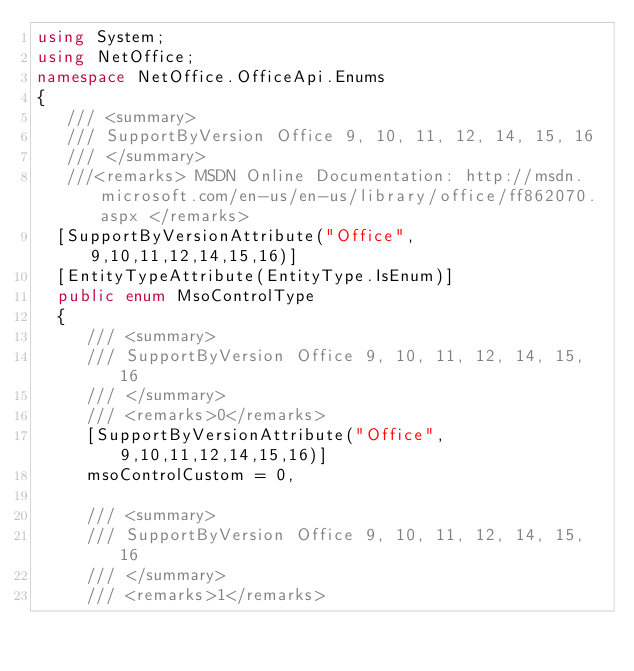Convert code to text. <code><loc_0><loc_0><loc_500><loc_500><_C#_>using System;
using NetOffice;
namespace NetOffice.OfficeApi.Enums
{
	 /// <summary>
	 /// SupportByVersion Office 9, 10, 11, 12, 14, 15, 16
	 /// </summary>
	 ///<remarks> MSDN Online Documentation: http://msdn.microsoft.com/en-us/en-us/library/office/ff862070.aspx </remarks>
	[SupportByVersionAttribute("Office", 9,10,11,12,14,15,16)]
	[EntityTypeAttribute(EntityType.IsEnum)]
	public enum MsoControlType
	{
		 /// <summary>
		 /// SupportByVersion Office 9, 10, 11, 12, 14, 15, 16
		 /// </summary>
		 /// <remarks>0</remarks>
		 [SupportByVersionAttribute("Office", 9,10,11,12,14,15,16)]
		 msoControlCustom = 0,

		 /// <summary>
		 /// SupportByVersion Office 9, 10, 11, 12, 14, 15, 16
		 /// </summary>
		 /// <remarks>1</remarks></code> 